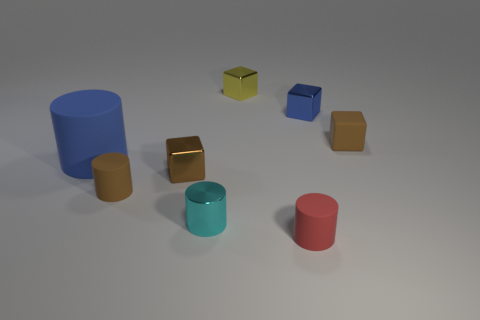There is a shiny cube that is to the right of the tiny red cylinder on the right side of the large blue matte object; what number of red rubber things are to the right of it?
Keep it short and to the point. 0. How many rubber things are to the left of the yellow metallic object?
Your answer should be compact. 2. What is the color of the block that is in front of the brown block that is to the right of the tiny blue metal object?
Offer a very short reply. Brown. How many other objects are there of the same material as the tiny cyan thing?
Offer a terse response. 3. Are there the same number of tiny cyan cylinders that are behind the cyan thing and yellow metallic cubes?
Your response must be concise. No. There is a blue thing in front of the blue thing behind the cube to the right of the small blue block; what is its material?
Offer a very short reply. Rubber. There is a cylinder that is in front of the small cyan metal cylinder; what is its color?
Give a very brief answer. Red. Is there anything else that has the same shape as the yellow thing?
Provide a short and direct response. Yes. There is a brown rubber thing that is in front of the brown rubber thing right of the tiny red matte cylinder; what size is it?
Your response must be concise. Small. Are there the same number of tiny cylinders behind the red rubber cylinder and cyan metallic things behind the yellow metallic object?
Your answer should be very brief. No. 